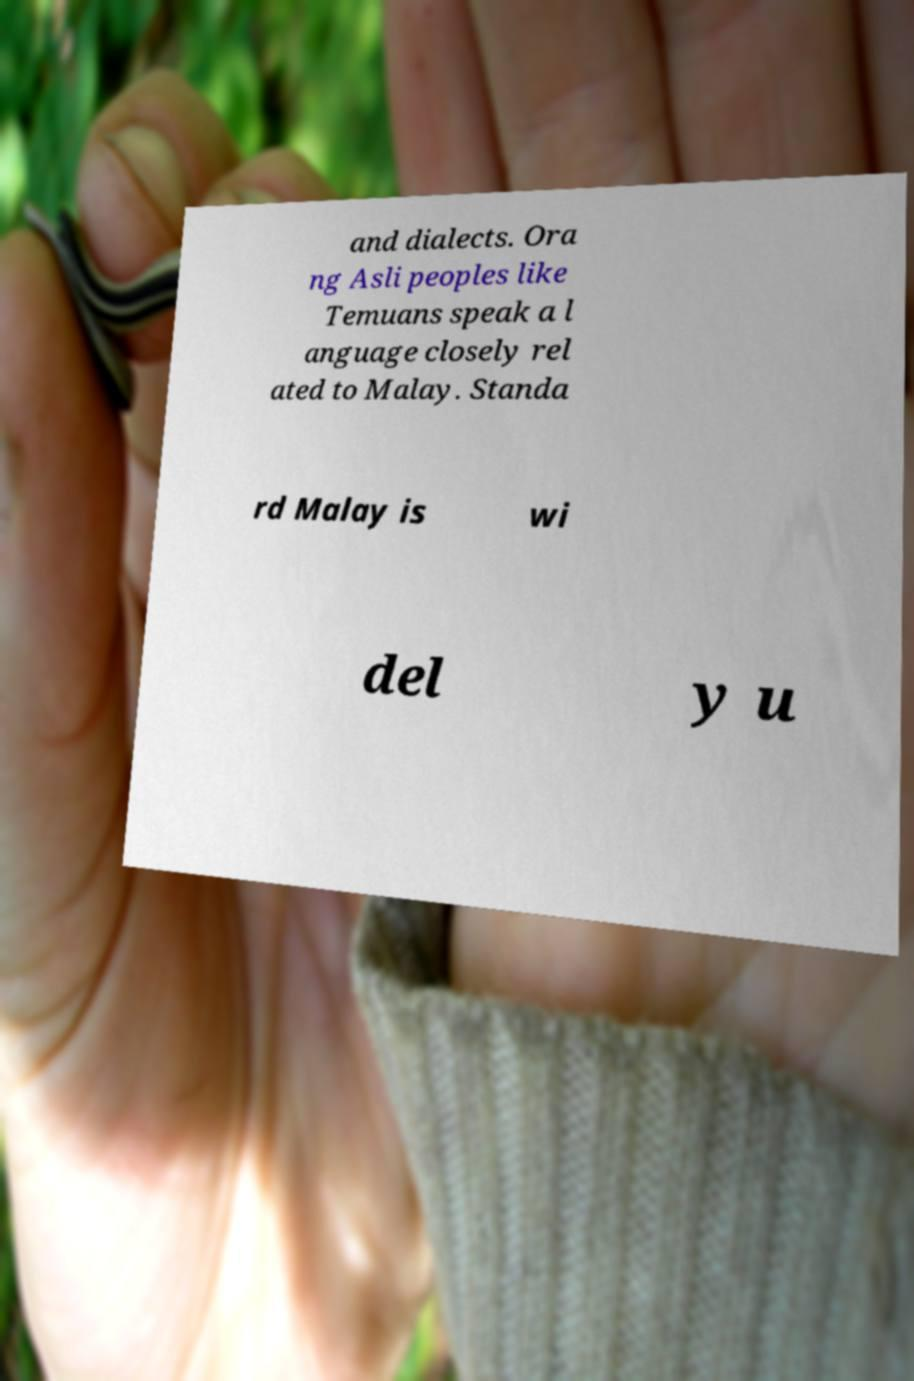For documentation purposes, I need the text within this image transcribed. Could you provide that? and dialects. Ora ng Asli peoples like Temuans speak a l anguage closely rel ated to Malay. Standa rd Malay is wi del y u 